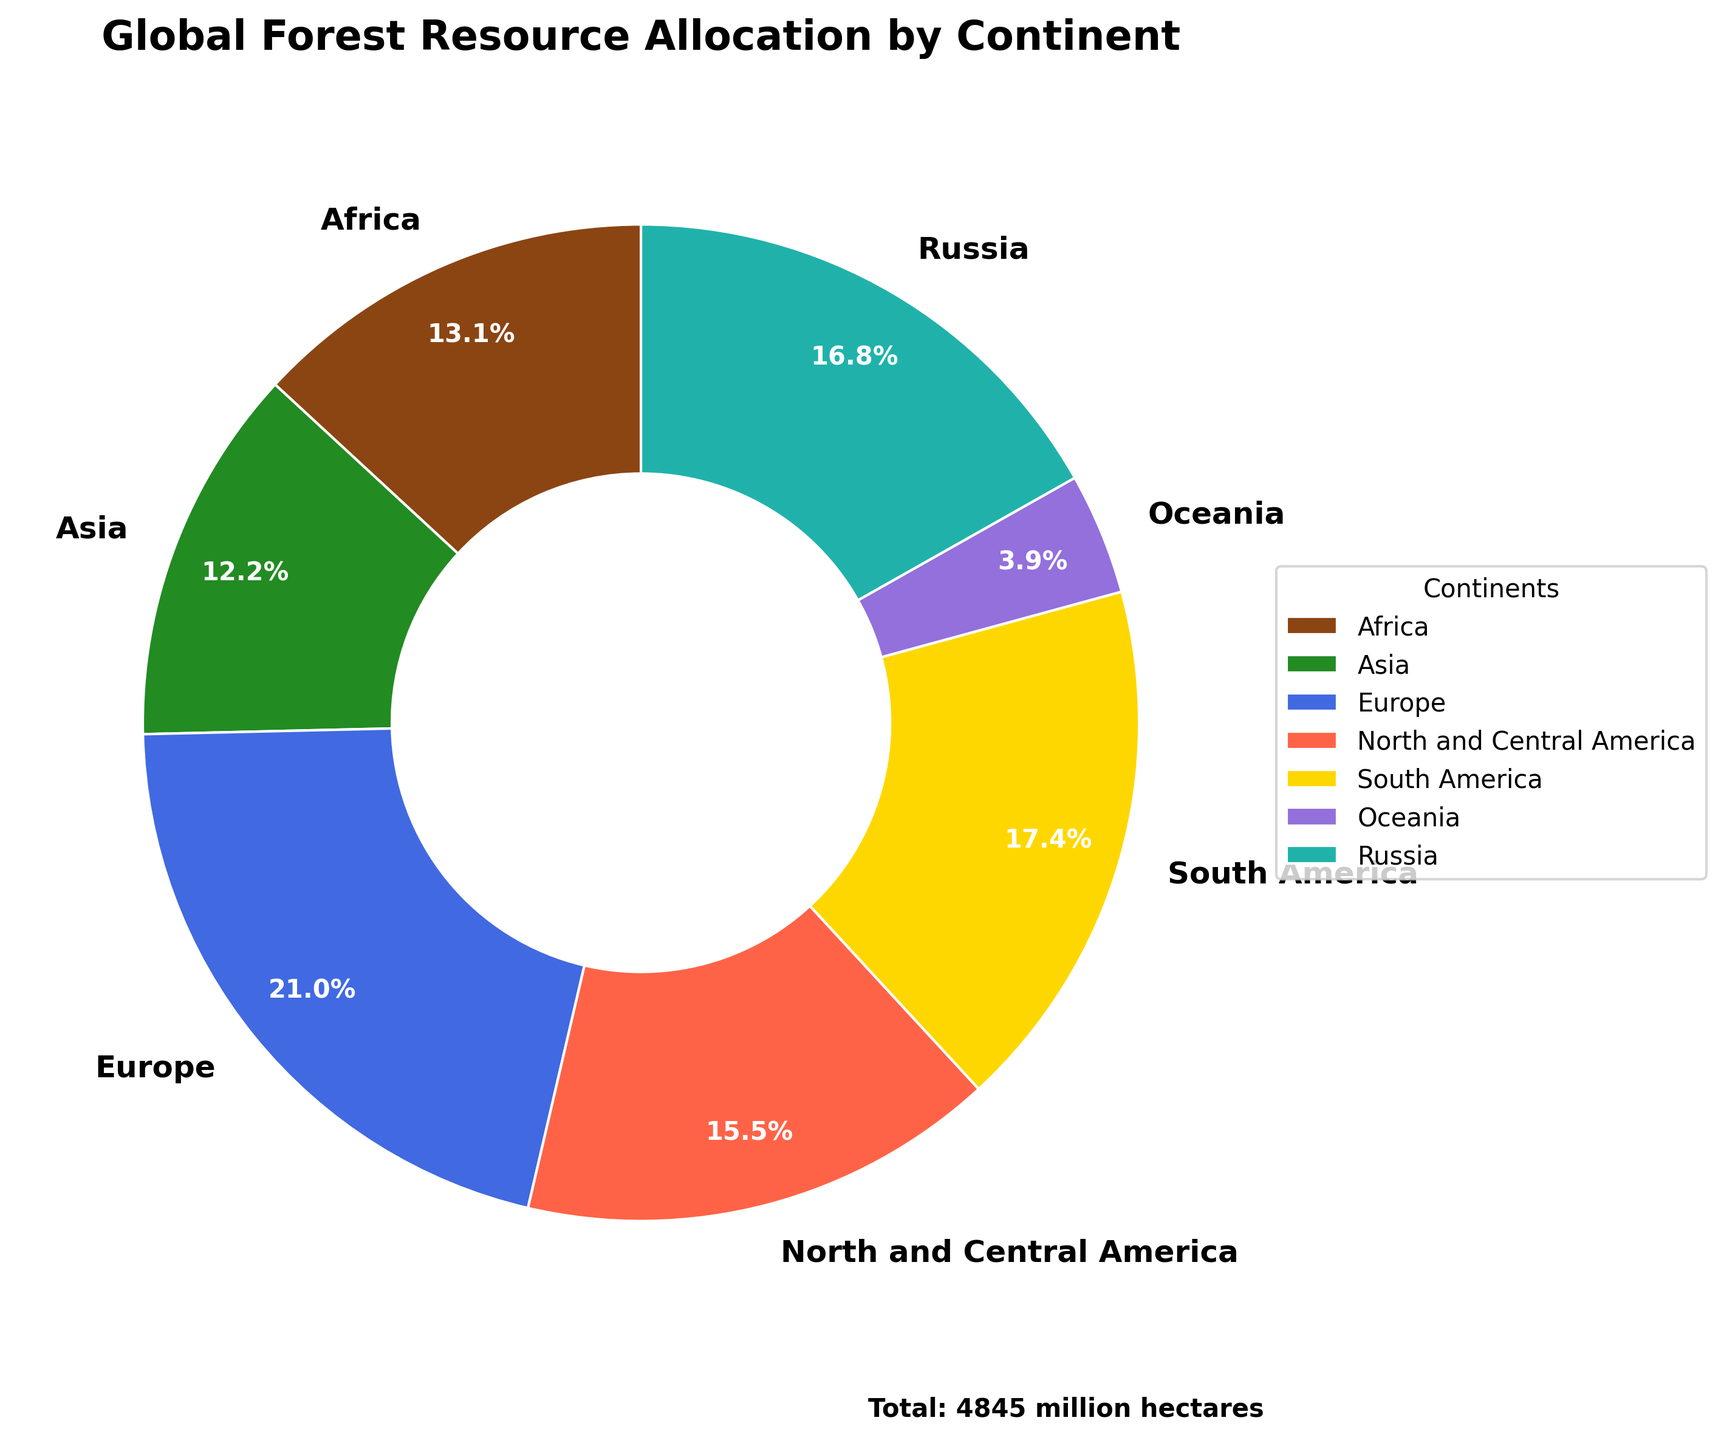What's the continent with the largest forest area? The pie chart shows each continent's forest area in millions of hectares. Europe has the largest segment in the pie, making it the continent with the most forest area.
Answer: Europe What's the total forest area covered by Africa and Asia combined? From the pie chart, Africa has 636 million hectares and Asia has 593 million hectares. Adding these together gives 636 + 593 = 1229 million hectares.
Answer: 1229 million hectares Which continent has a larger forest area, North and Central America or Russia? The chart shows Russia with 815 million hectares and North and Central America with 751 million hectares. Since 815 is greater than 751, Russia has a larger forest area.
Answer: Russia What percentage of the total forest area is covered by Oceania? According to the pie chart, Oceania is labeled with its percentage share. Looking at the segment, Oceania covers 191 million hectares, and the total is 4845 million hectares. The percentage is (191/4845) * 100 = 3.9%.
Answer: 3.9% How much more forest area does South America have compared to Africa? The chart shows South America with 842 million hectares and Africa with 636 million hectares. The difference is 842 - 636 = 206 million hectares.
Answer: 206 million hectares What color represents Asia in the pie chart? The pie chart uses specific colors for each continent. Asia is represented by the color green.
Answer: Green If you combine the forest areas of Europe and Russia, what fraction of the total forest area does this represent? Europe has 1017 million hectares, and Russia has 815 million hectares. The combined area is 1017 + 815 = 1832 million hectares. The total forest area is 4845 million hectares. The fraction is 1832 / 4845, which simplifies approximately to 0.38.
Answer: 0.38 Compare the forest areas of Oceania and Europe. How many times larger is Europe's forest area compared to Oceania's? Europe has 1017 million hectares of forest and Oceania has 191 million hectares. To find out how many times larger, divide 1017 by 191, giving approximately 5.32 times larger.
Answer: 5.32 Which two continents combined have a forest area closest to the total forest area of Russia? Russia has 815 million hectares. Combining Asia (593) and North and Central America (751) gives 593 + 751 = 1344 million hectares, which is more than Russia. Combining Africa (636) and Oceania (191) gives 636 + 191 = 827 million hectares, which is closer to Russia's total.
Answer: Africa and Oceania What is the smallest forest area among all continents shown in the pie chart, and what is its value? The smallest segment in the pie chart represents Oceania with a forest area of 191 million hectares.
Answer: Oceania, 191 million hectares 